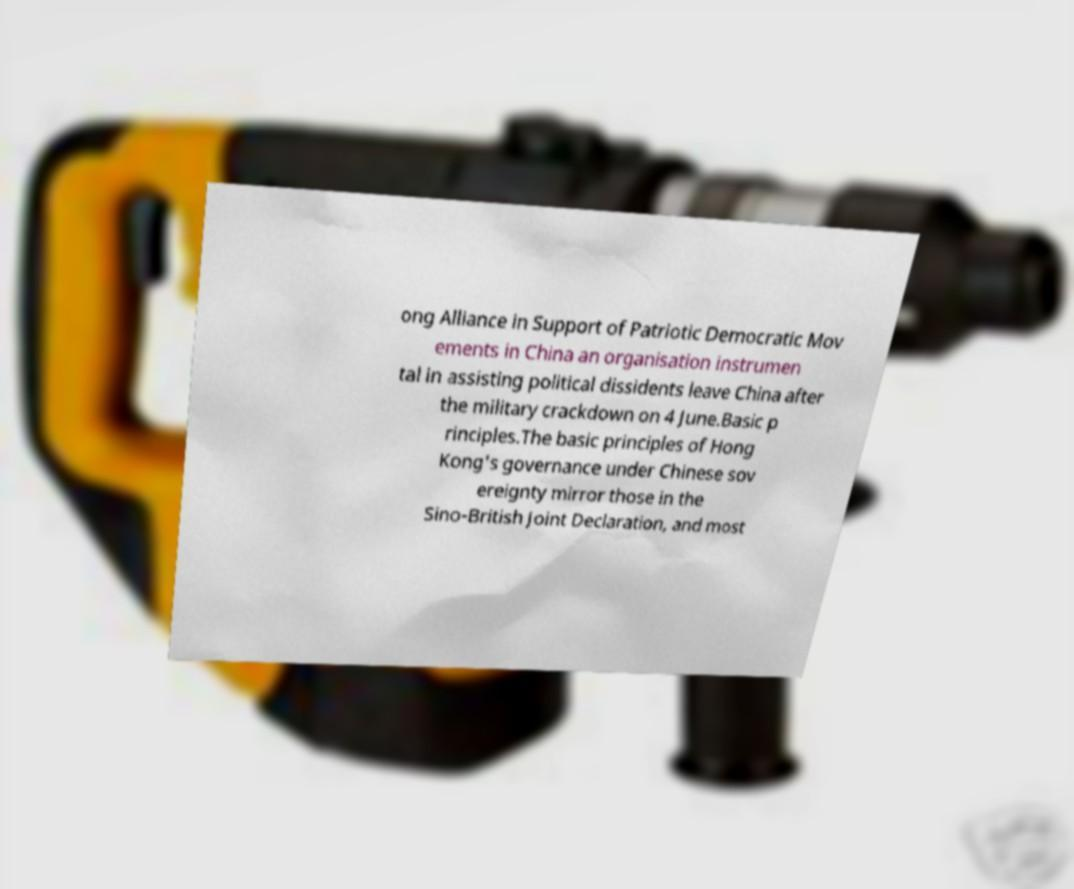Could you extract and type out the text from this image? ong Alliance in Support of Patriotic Democratic Mov ements in China an organisation instrumen tal in assisting political dissidents leave China after the military crackdown on 4 June.Basic p rinciples.The basic principles of Hong Kong's governance under Chinese sov ereignty mirror those in the Sino-British Joint Declaration, and most 